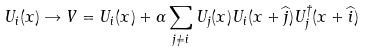<formula> <loc_0><loc_0><loc_500><loc_500>U _ { i } ( x ) \rightarrow V = U _ { i } ( x ) + \alpha \sum _ { j \neq i } U _ { j } ( x ) U _ { i } ( x + \widehat { j } ) U ^ { \dagger } _ { j } ( x + \widehat { i } )</formula> 